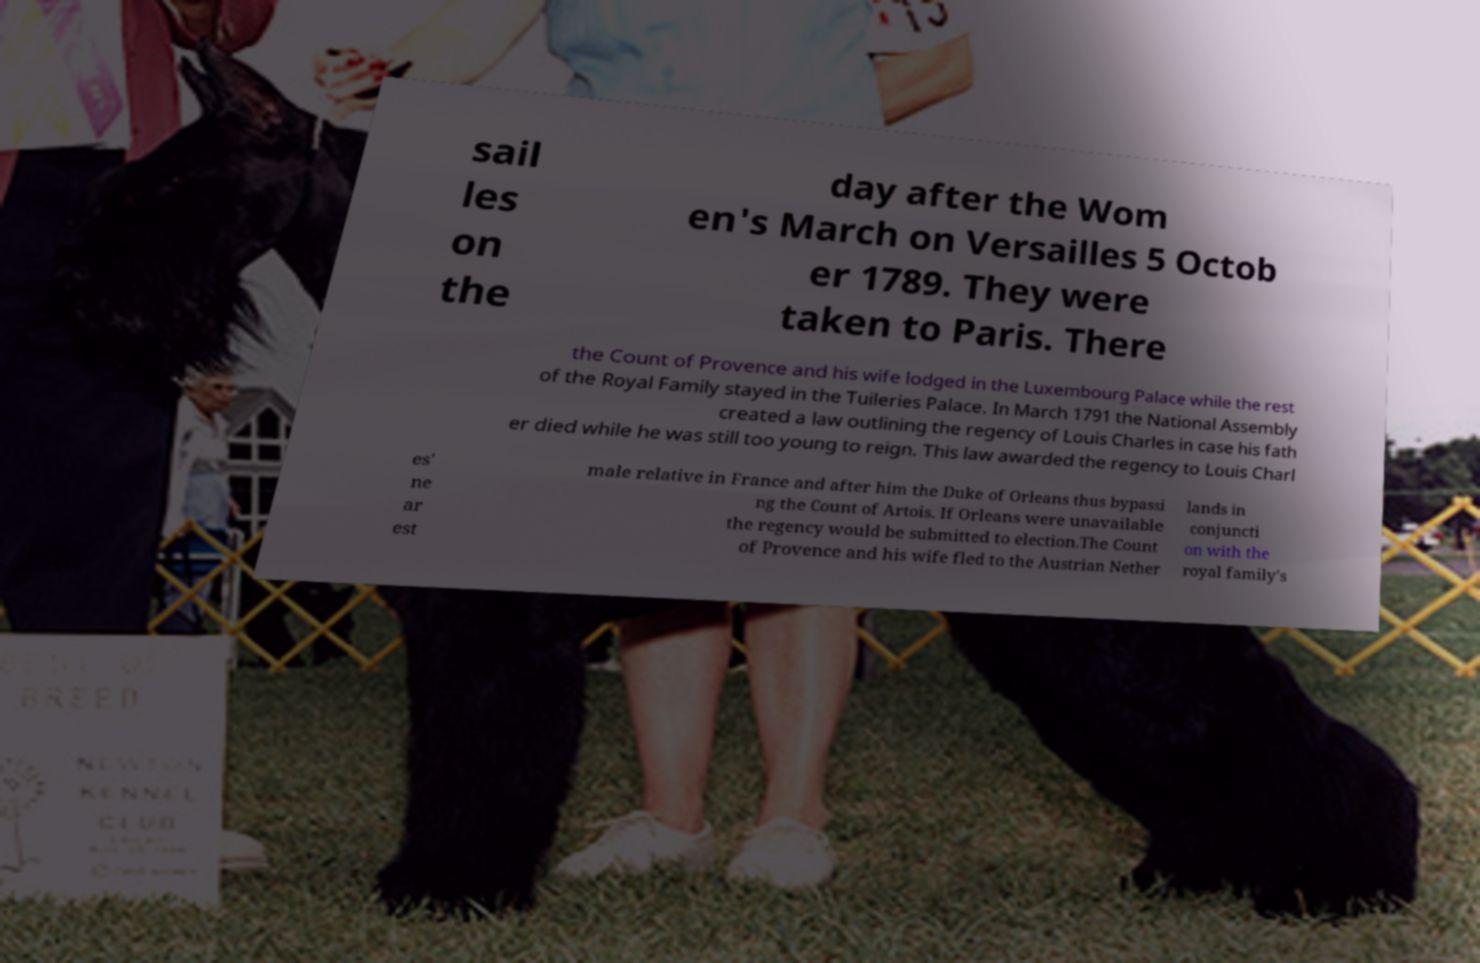For documentation purposes, I need the text within this image transcribed. Could you provide that? sail les on the day after the Wom en's March on Versailles 5 Octob er 1789. They were taken to Paris. There the Count of Provence and his wife lodged in the Luxembourg Palace while the rest of the Royal Family stayed in the Tuileries Palace. In March 1791 the National Assembly created a law outlining the regency of Louis Charles in case his fath er died while he was still too young to reign. This law awarded the regency to Louis Charl es' ne ar est male relative in France and after him the Duke of Orleans thus bypassi ng the Count of Artois. If Orleans were unavailable the regency would be submitted to election.The Count of Provence and his wife fled to the Austrian Nether lands in conjuncti on with the royal family's 